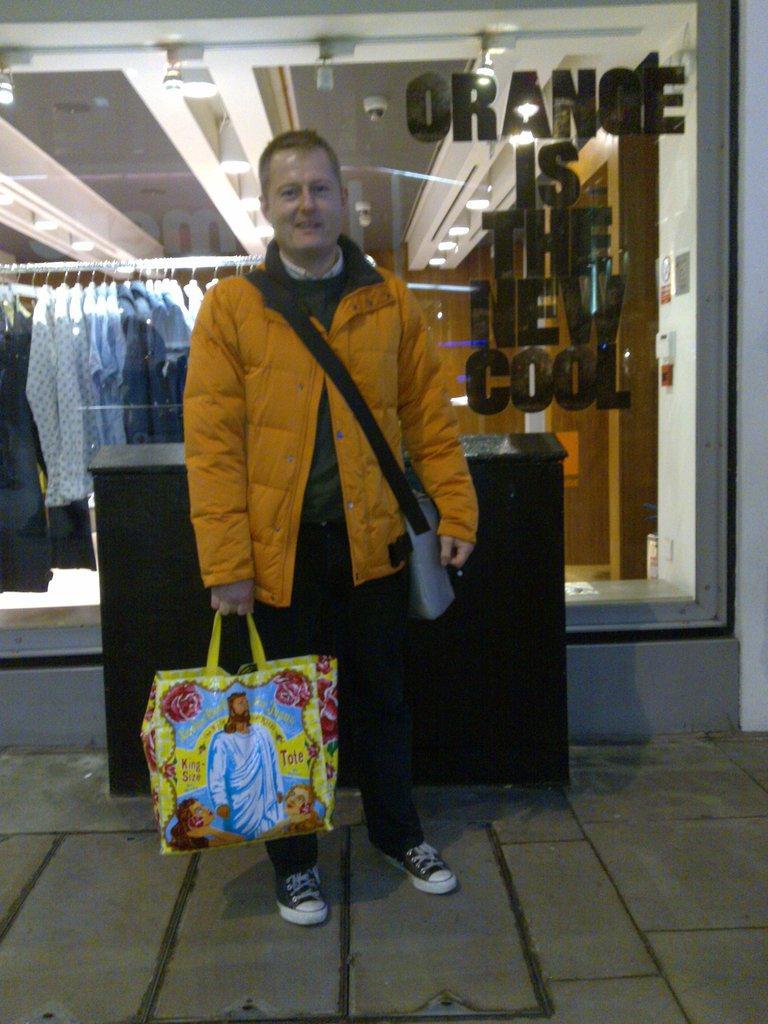Could you give a brief overview of what you see in this image? In this image i can see a person standing in front of a shop and there are some clothes kept on the hanger and there is some text written on the glass of the window and the person holding a carry bag on his hand 